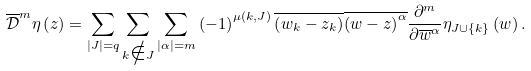Convert formula to latex. <formula><loc_0><loc_0><loc_500><loc_500>\overline { \mathcal { D } } ^ { m } \eta \left ( z \right ) = \sum _ { \left | J \right | = q } \sum _ { k \notin J } \sum _ { \left | \alpha \right | = m } \left ( - 1 \right ) ^ { \mu \left ( k , J \right ) } \overline { \left ( w _ { k } - z _ { k } \right ) } \overline { \left ( w - z \right ) ^ { \alpha } } \frac { \partial ^ { m } } { \partial \overline { w } ^ { \alpha } } \eta _ { J \cup \left \{ k \right \} } \left ( w \right ) .</formula> 